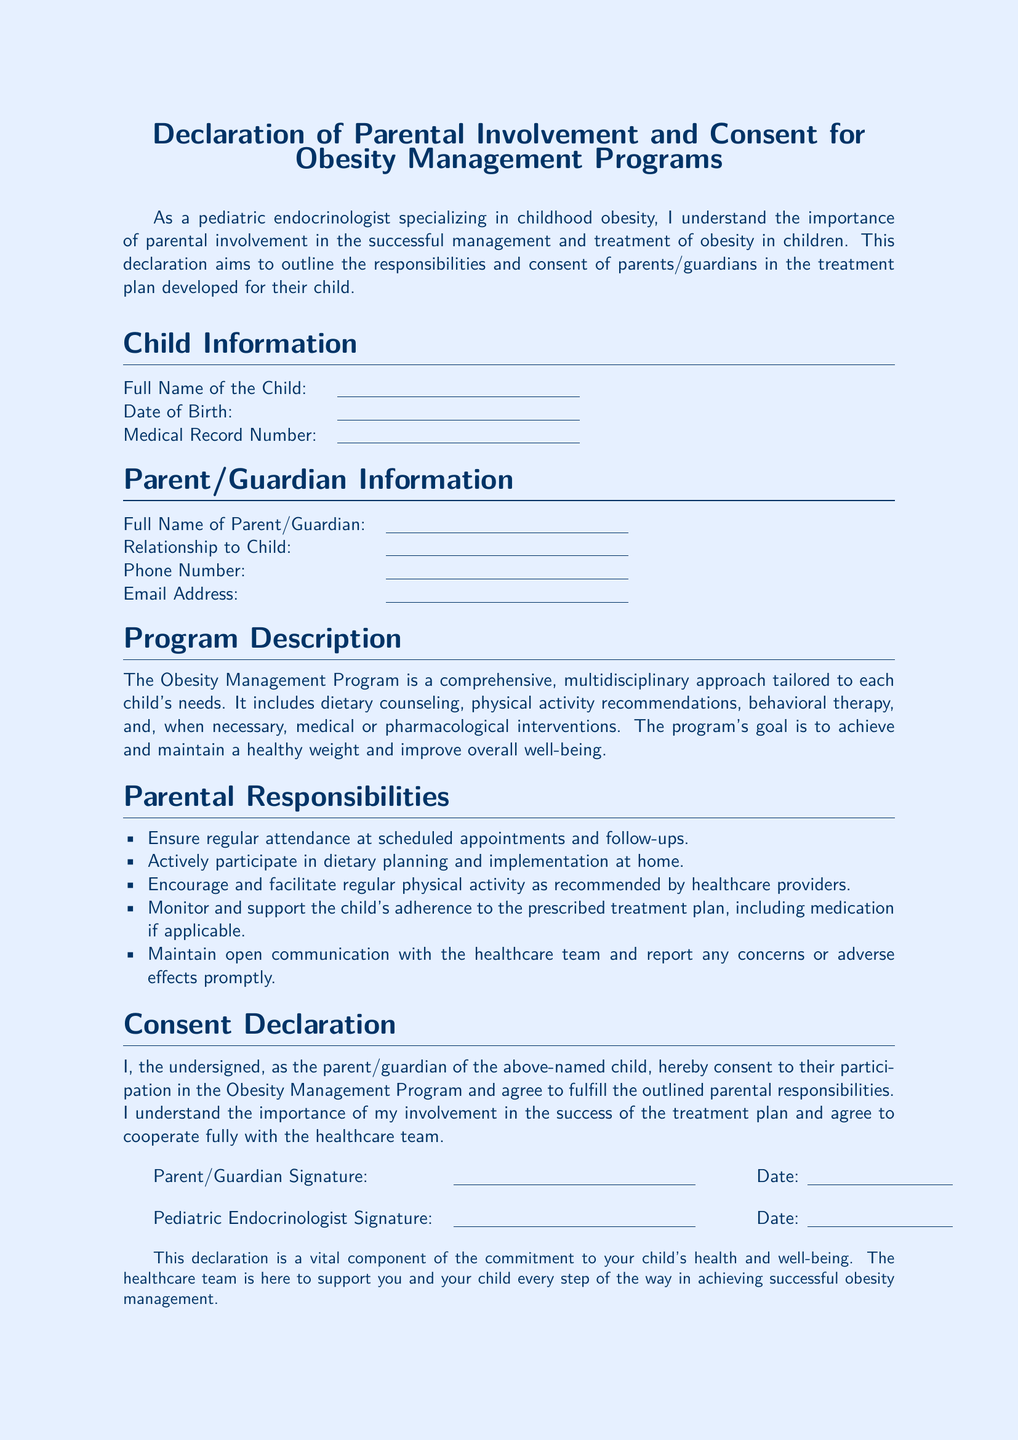What is the title of the document? The title of the document is stated at the top and summarizes its purpose.
Answer: Declaration of Parental Involvement and Consent for Obesity Management Programs What is the date format required for the signatures? The document does not specify the exact format, but it indicates a space for the date following the signatures.
Answer: A space for the date What is one of the parental responsibilities listed? The document lists several responsibilities pertaining to the role of parents in the obesity management program.
Answer: Ensure regular attendance at scheduled appointments and follow-ups Who must sign the declaration? The document specifies who is required to provide their signature to validate the declaration.
Answer: Parent/Guardian and Pediatric Endocrinologist What is the purpose of the Obesity Management Program? The document outlines the goal of the program in relation to the health of the child.
Answer: Achieve and maintain a healthy weight and improve overall well-being Which type of interventions may be included in the program? The document describes types of interventions incorporated within the obesity management approach.
Answer: Medical or pharmacological interventions What is emphasized as important for the treatment plan's success? The document highlights a key aspect concerning participant involvement in the child's treatment.
Answer: Parental involvement What should parents do if they have concerns about the child's treatment? The document advises on the action parents should take if issues arise during treatment.
Answer: Maintain open communication with the healthcare team and report any concerns or adverse effects promptly 